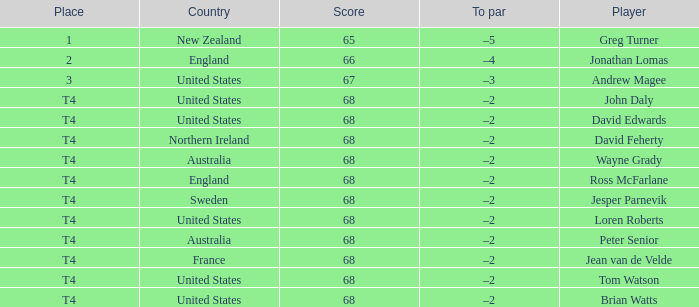Which To par has a Place of t4, and wayne grady is in? –2. 